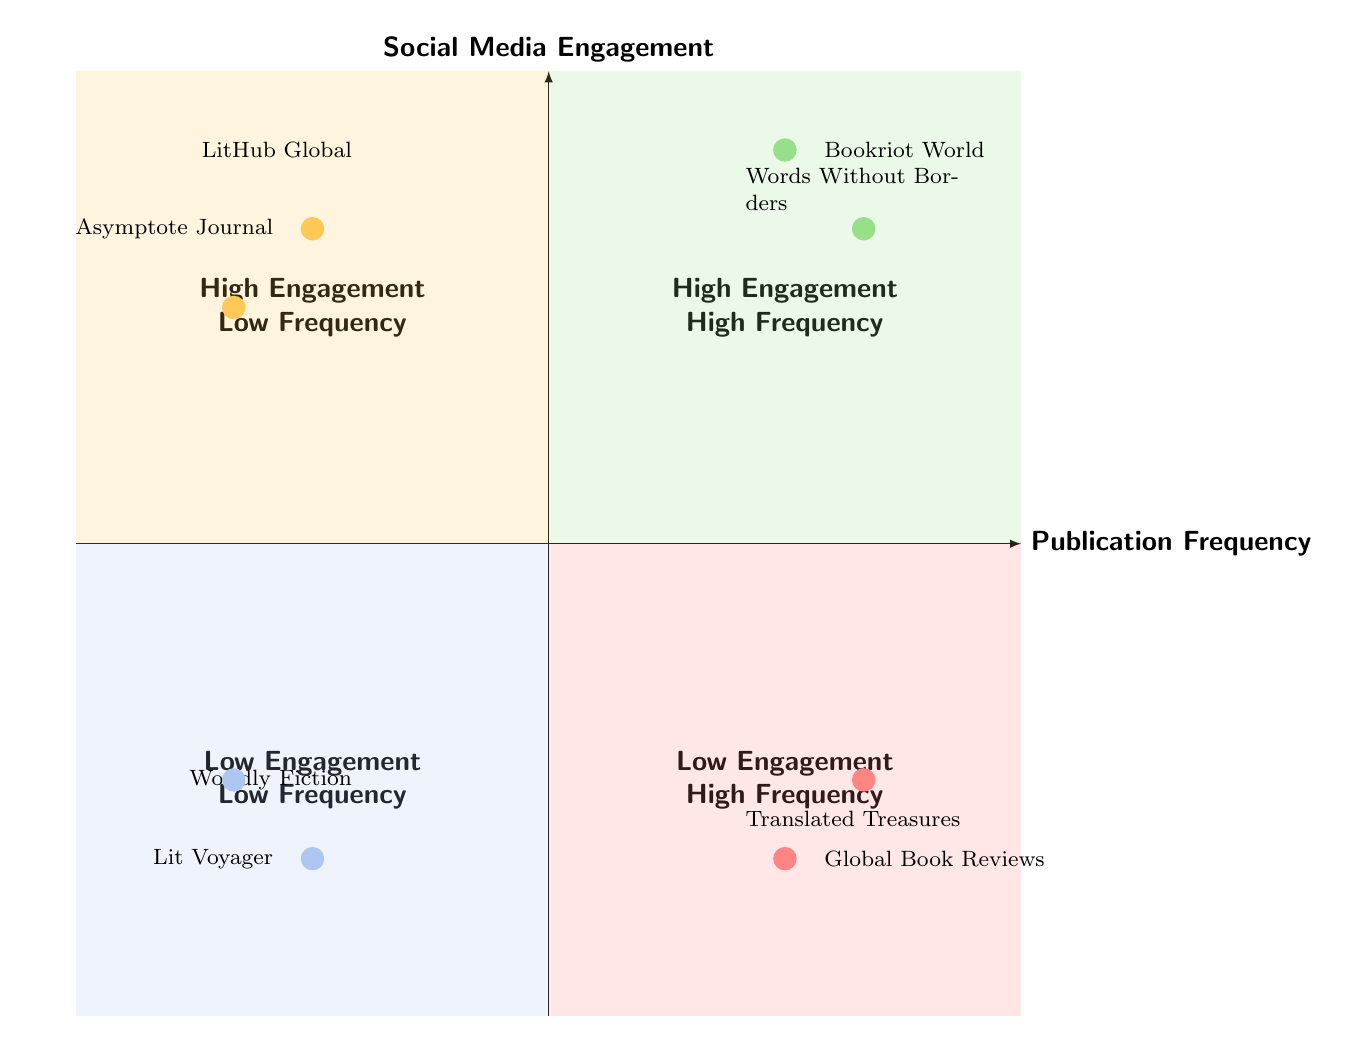What blogs are in the High Engagement - High Frequency quadrant? The High Engagement - High Frequency quadrant contains the blogs "Bookriot World" and "Words Without Borders". These blogs are indicated in the upper right section of the diagram.
Answer: Bookriot World, Words Without Borders How many blogs are in the Low Engagement - Low Frequency quadrant? The Low Engagement - Low Frequency quadrant has two blogs: "Worldly Fiction" and "Lit Voyager". Counting the blogs in the bottom left quadrant gives us this total.
Answer: 2 Which blog engages high but publishes less frequently? The blog "LitHub Global" fits this description as it is located in the High Engagement - Low Frequency quadrant of the diagram.
Answer: LitHub Global What is the characteristic of the blogs in the Low Engagement - High Frequency quadrant? Blogs in the Low Engagement - High Frequency quadrant, like "Global Book Reviews" and "Translated Treasures", publish frequently but do not engage their audience effectively. This trend is shown in the lower right area of the diagram.
Answer: Frequent publishing, low engagement Why do you think "Words Without Borders" has high engagement and frequency? "Words Without Borders" likely has high engagement and frequency due to its focus on promoting lesser-known Turkish authors and its regular features and social media campaigns that attract audience interaction. This reasoning combines the blog's description and quadrant placement.
Answer: High engagement and frequency due to features and campaigns Which blog has the highest frequency but the lowest engagement? "Translated Treasures" belongs to the Low Engagement - High Frequency quadrant and is noted for its regular posts but struggles with engagement. This leads us to identify it as the blog with the highest frequency and lowest engagement.
Answer: Translated Treasures How many blogs are published quarterly? "Asymptote Journal" and "Lit Voyager" publish quarterly updates, indicated by their descriptions tied to infrequent publication schedules. Hence, the total is two.
Answer: 2 What indicates a blog's position in the Low Engagement - High Frequency quadrant? Blogs like "Global Book Reviews" and "Translated Treasures" in the Low Engagement - High Frequency quadrant indicate that, despite their frequent posts, they fail to retain a consistent audience or generate engagement.
Answer: Frequent posts, low engagement 